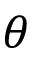Convert formula to latex. <formula><loc_0><loc_0><loc_500><loc_500>\theta</formula> 